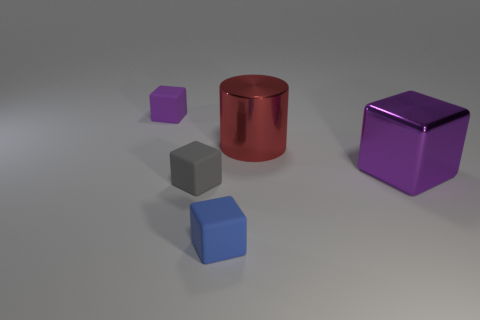What is the color of the metallic cube that is the same size as the red thing?
Make the answer very short. Purple. Are there any big matte objects of the same color as the metal cube?
Provide a short and direct response. No. The blue object that is the same material as the tiny gray block is what size?
Your answer should be very brief. Small. What size is the matte cube that is the same color as the metallic block?
Your response must be concise. Small. How many other things are there of the same size as the blue rubber cube?
Offer a terse response. 2. What is the material of the large cylinder that is to the right of the gray block?
Offer a very short reply. Metal. The purple object that is to the right of the small rubber cube that is behind the purple thing right of the small blue rubber cube is what shape?
Provide a succinct answer. Cube. Do the gray rubber object and the blue matte cube have the same size?
Provide a succinct answer. Yes. What number of objects are either blue objects or blocks that are in front of the red thing?
Provide a succinct answer. 3. What number of objects are matte cubes that are behind the tiny blue rubber cube or small matte blocks behind the gray block?
Provide a succinct answer. 2. 